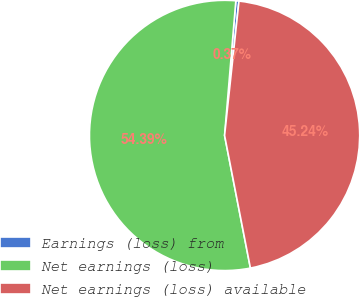<chart> <loc_0><loc_0><loc_500><loc_500><pie_chart><fcel>Earnings (loss) from<fcel>Net earnings (loss)<fcel>Net earnings (loss) available<nl><fcel>0.37%<fcel>54.39%<fcel>45.24%<nl></chart> 